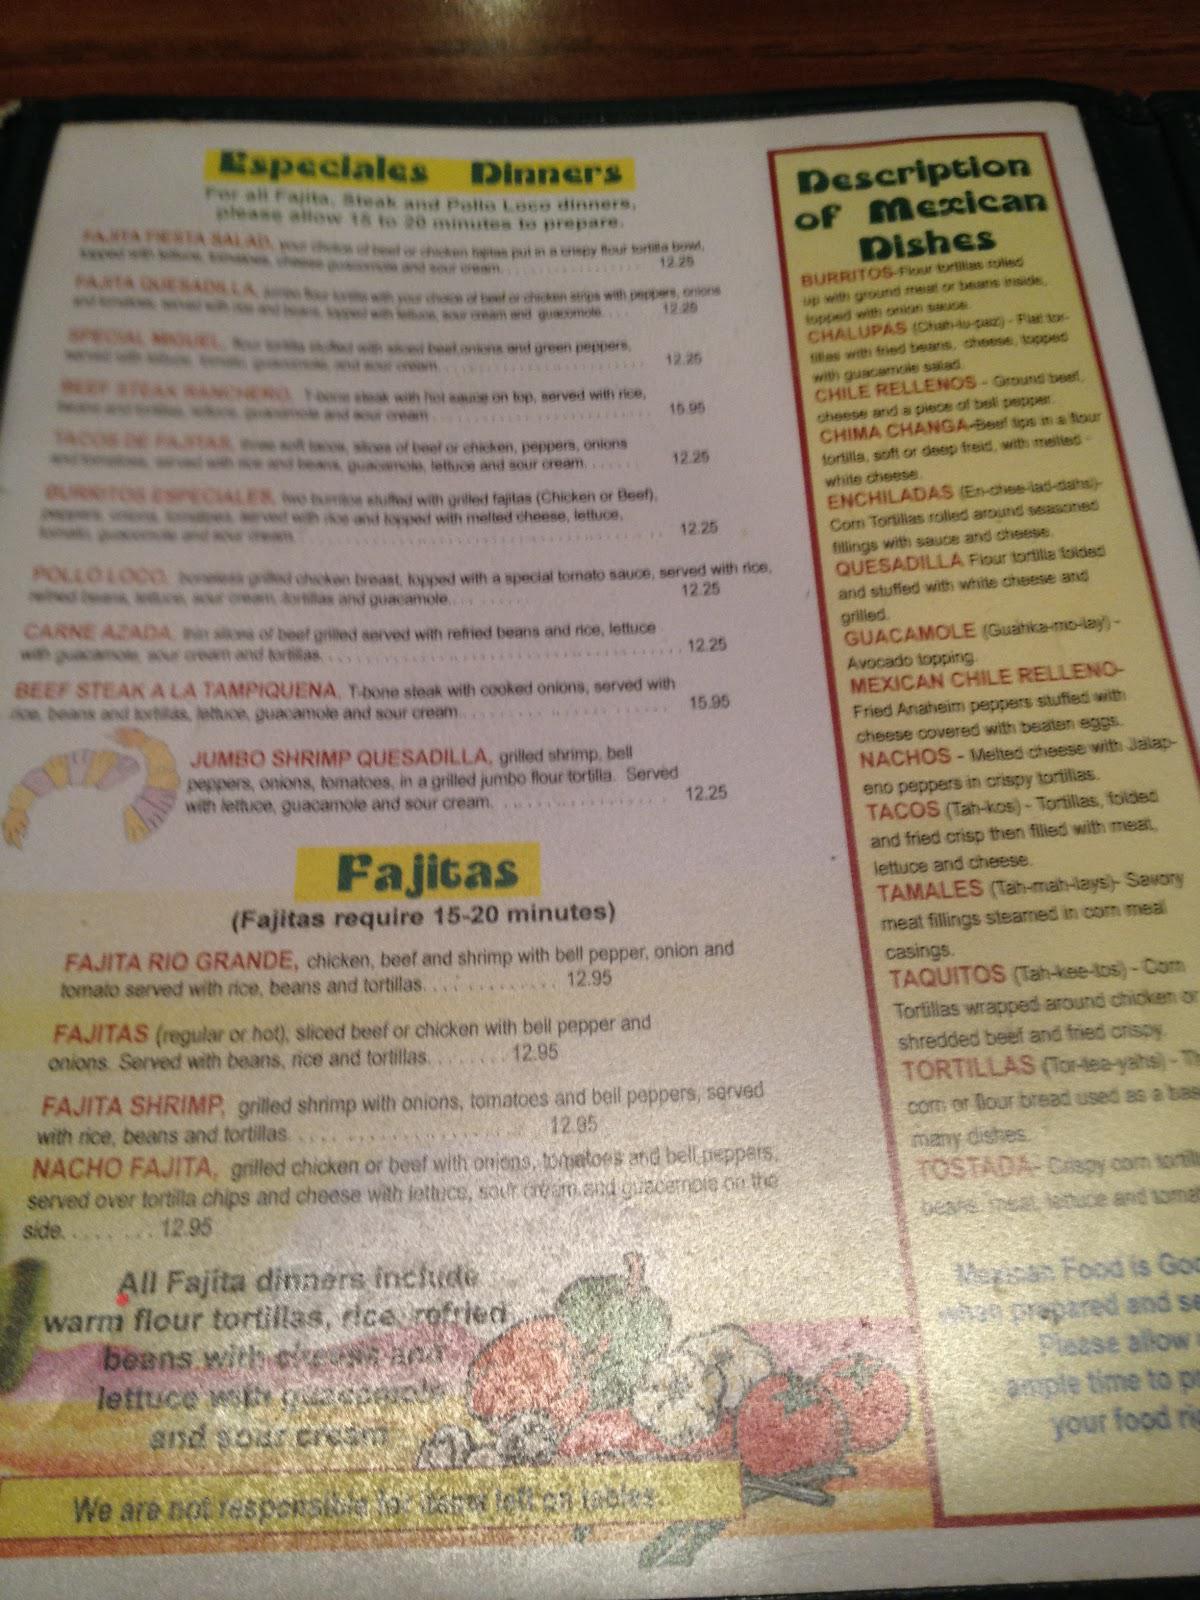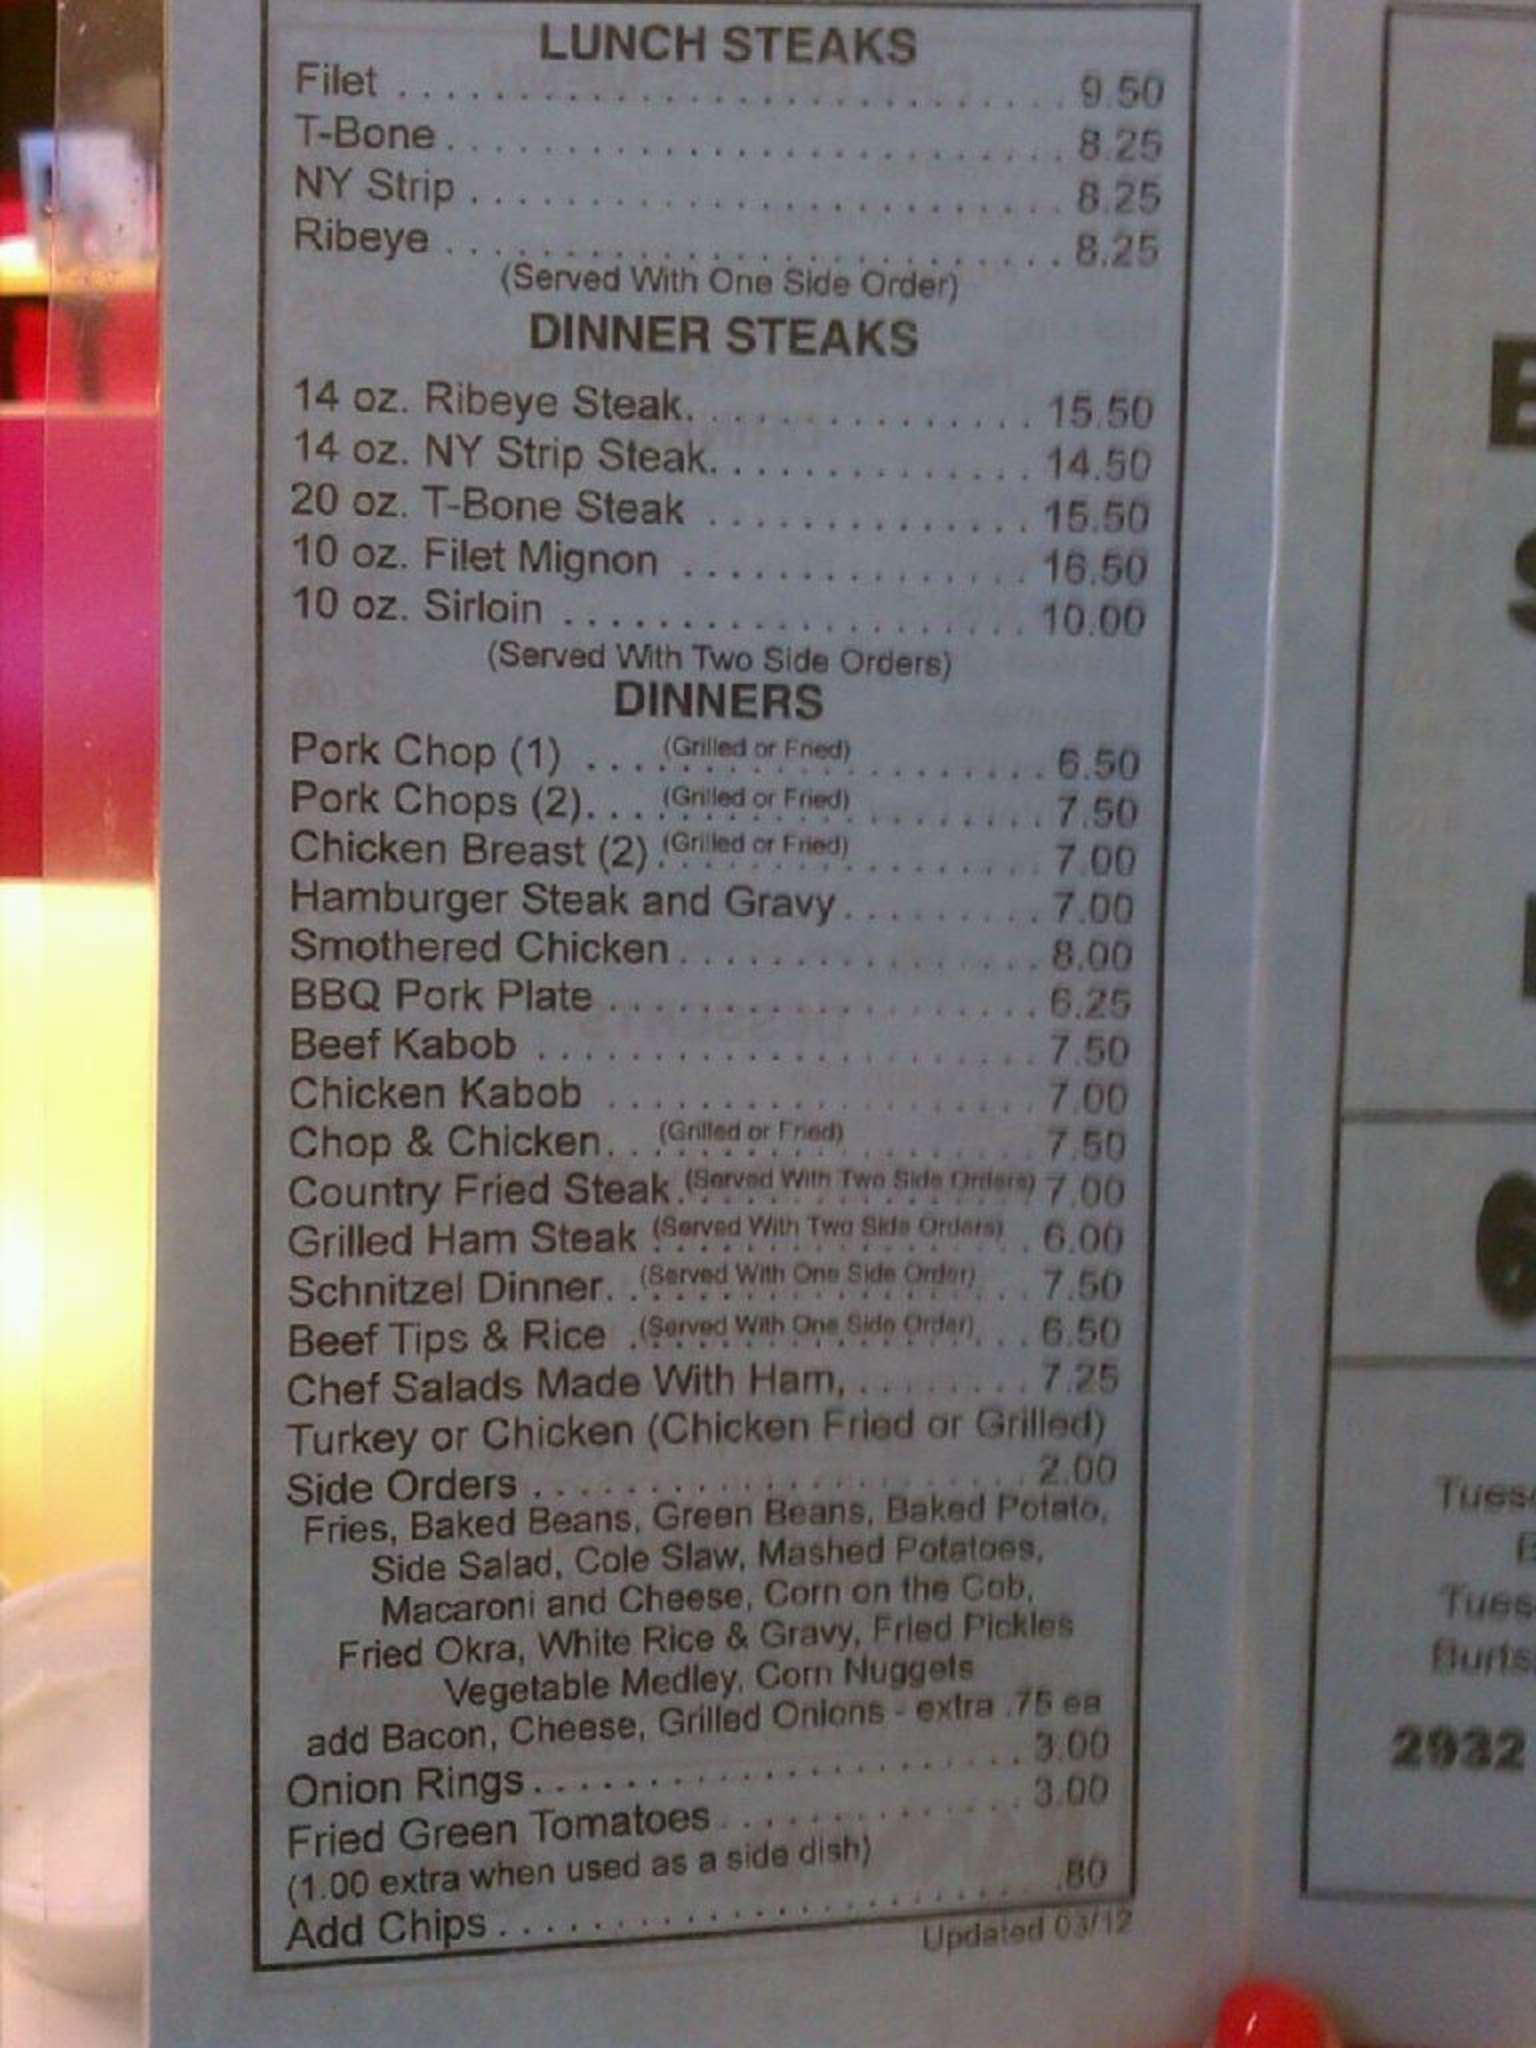The first image is the image on the left, the second image is the image on the right. Evaluate the accuracy of this statement regarding the images: "The right image shows a diner exterior with a rectangular sign over glass windows in front of a parking lot.". Is it true? Answer yes or no. No. The first image is the image on the left, the second image is the image on the right. For the images displayed, is the sentence "Both images contain menus." factually correct? Answer yes or no. Yes. 